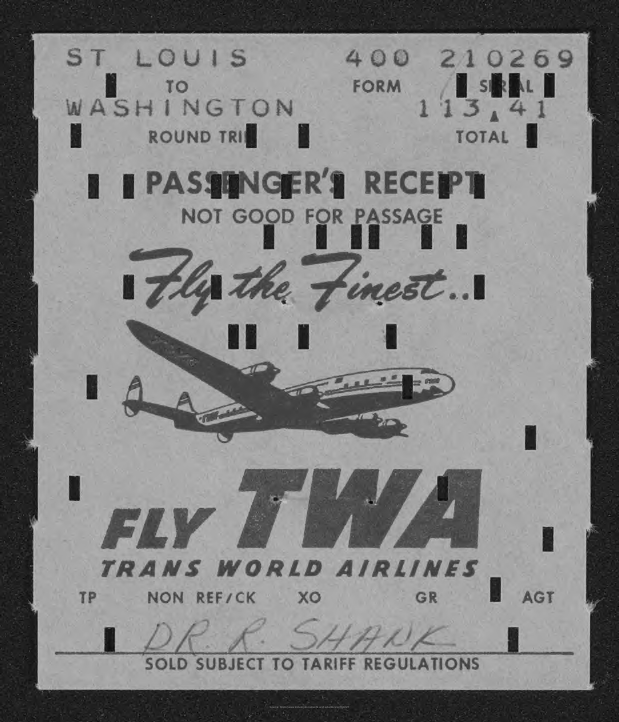What is the passenger name mentioned in the receipt?
Keep it short and to the point. Dr. R. Shank. 